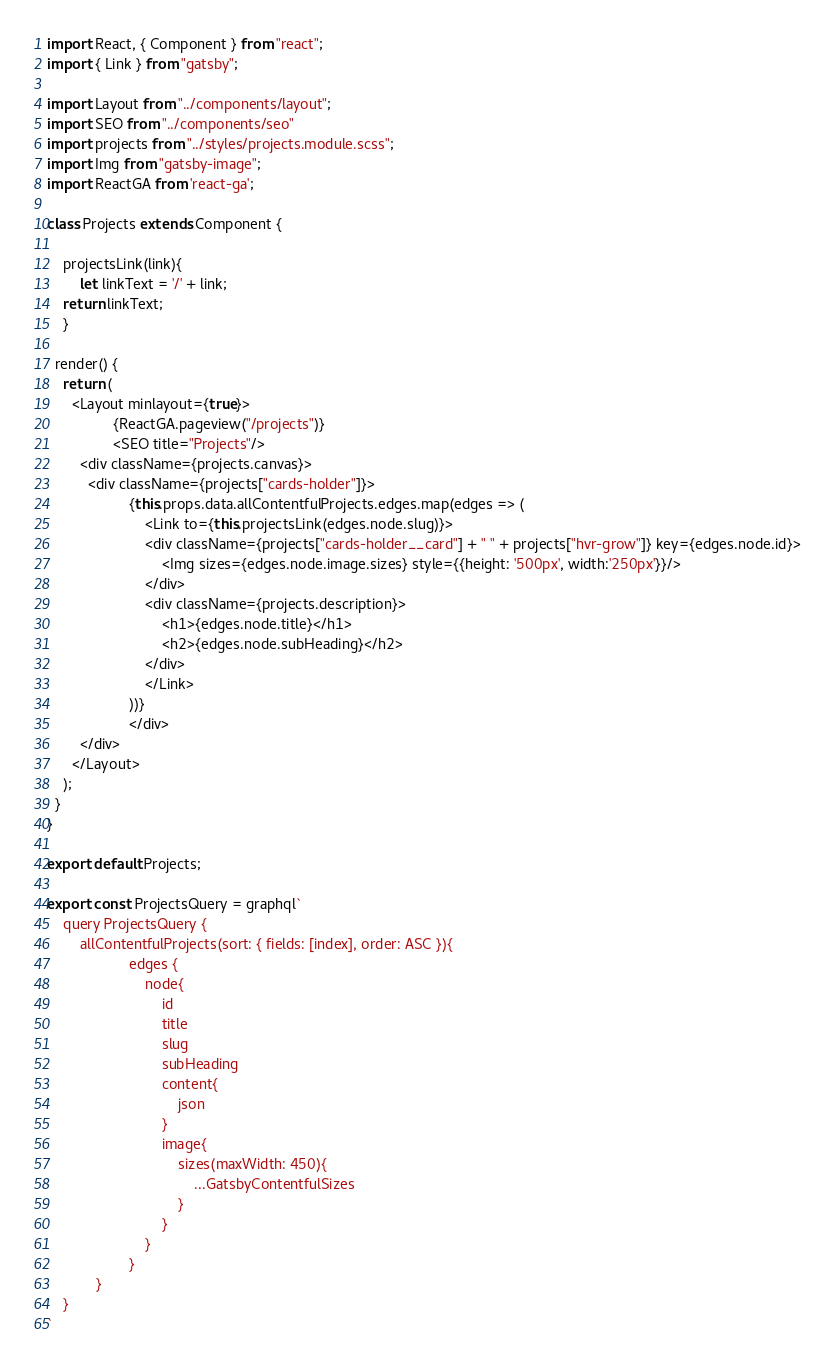Convert code to text. <code><loc_0><loc_0><loc_500><loc_500><_JavaScript_>import React, { Component } from "react";
import { Link } from "gatsby";

import Layout from "../components/layout";
import SEO from "../components/seo"
import projects from "../styles/projects.module.scss";
import Img from "gatsby-image";
import ReactGA from 'react-ga';

class Projects extends Component {

	projectsLink(link){
		let linkText = '/' + link;
    return linkText;
	}

  render() {
    return (
      <Layout minlayout={true}>
				{ReactGA.pageview("/projects")}
				<SEO title="Projects"/>
        <div className={projects.canvas}>
          <div className={projects["cards-holder"]}>
					{this.props.data.allContentfulProjects.edges.map(edges => (
						<Link to={this.projectsLink(edges.node.slug)}>
						<div className={projects["cards-holder__card"] + " " + projects["hvr-grow"]} key={edges.node.id}>
							<Img sizes={edges.node.image.sizes} style={{height: '500px', width:'250px'}}/>
						</div>
						<div className={projects.description}>
							<h1>{edges.node.title}</h1>
							<h2>{edges.node.subHeading}</h2>
						</div>
						</Link>
					))}
					</div>
        </div>
      </Layout>
    );
  }
}

export default Projects;

export const ProjectsQuery = graphql`
    query ProjectsQuery {
        allContentfulProjects(sort: { fields: [index], order: ASC }){
					edges {
						node{
							id
							title
							slug
							subHeading
							content{
								json
							}
							image{
								sizes(maxWidth: 450){
									...GatsbyContentfulSizes
								}
							}
						}
					}
			}
    }
`</code> 